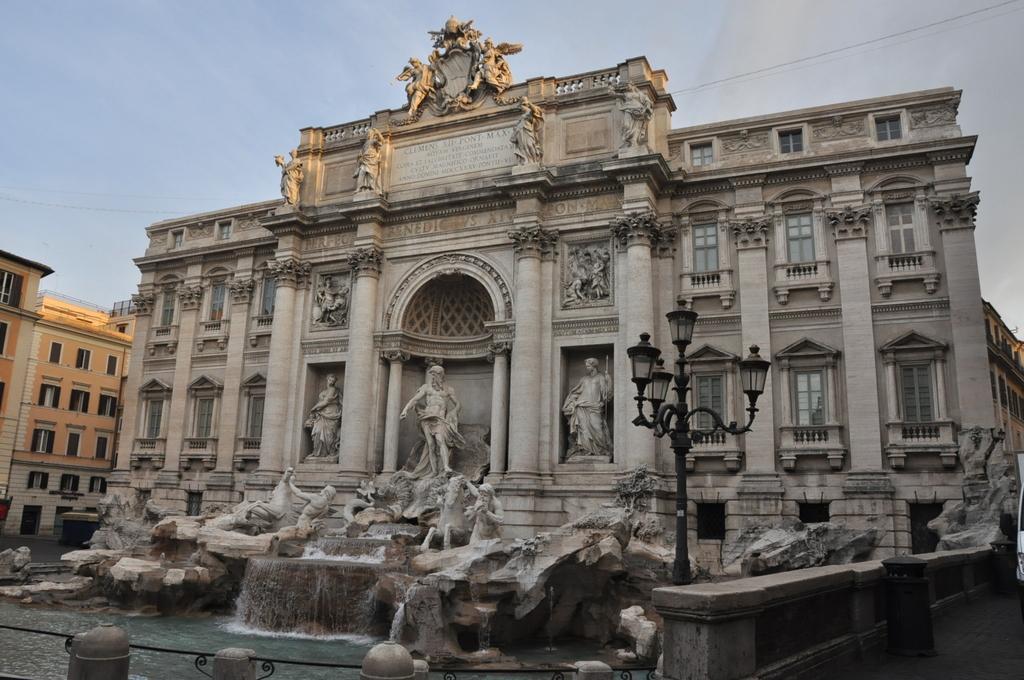Describe this image in one or two sentences. In this picture I can see buildings. On this building I can see some sculptures. Here I can see street lights and water. In the background I can see the sky. 